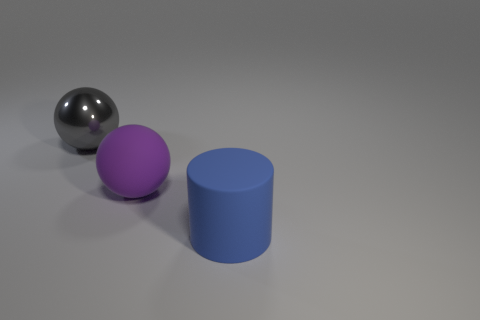Subtract all gray spheres. How many spheres are left? 1 Subtract all cylinders. How many objects are left? 2 Add 3 purple objects. How many objects exist? 6 Subtract 0 cyan blocks. How many objects are left? 3 Subtract all gray cylinders. Subtract all cyan cubes. How many cylinders are left? 1 Subtract all small cylinders. Subtract all big blue rubber cylinders. How many objects are left? 2 Add 1 big matte balls. How many big matte balls are left? 2 Add 3 tiny yellow cubes. How many tiny yellow cubes exist? 3 